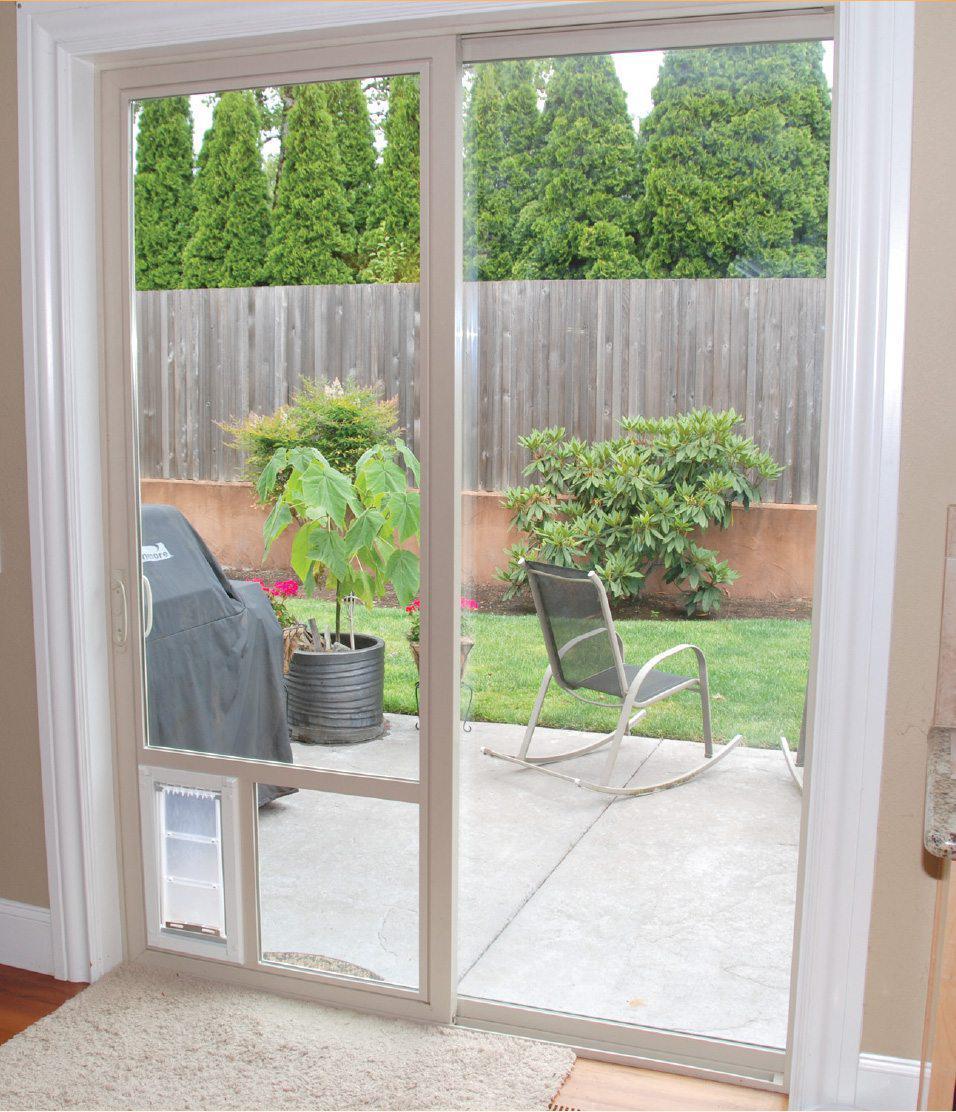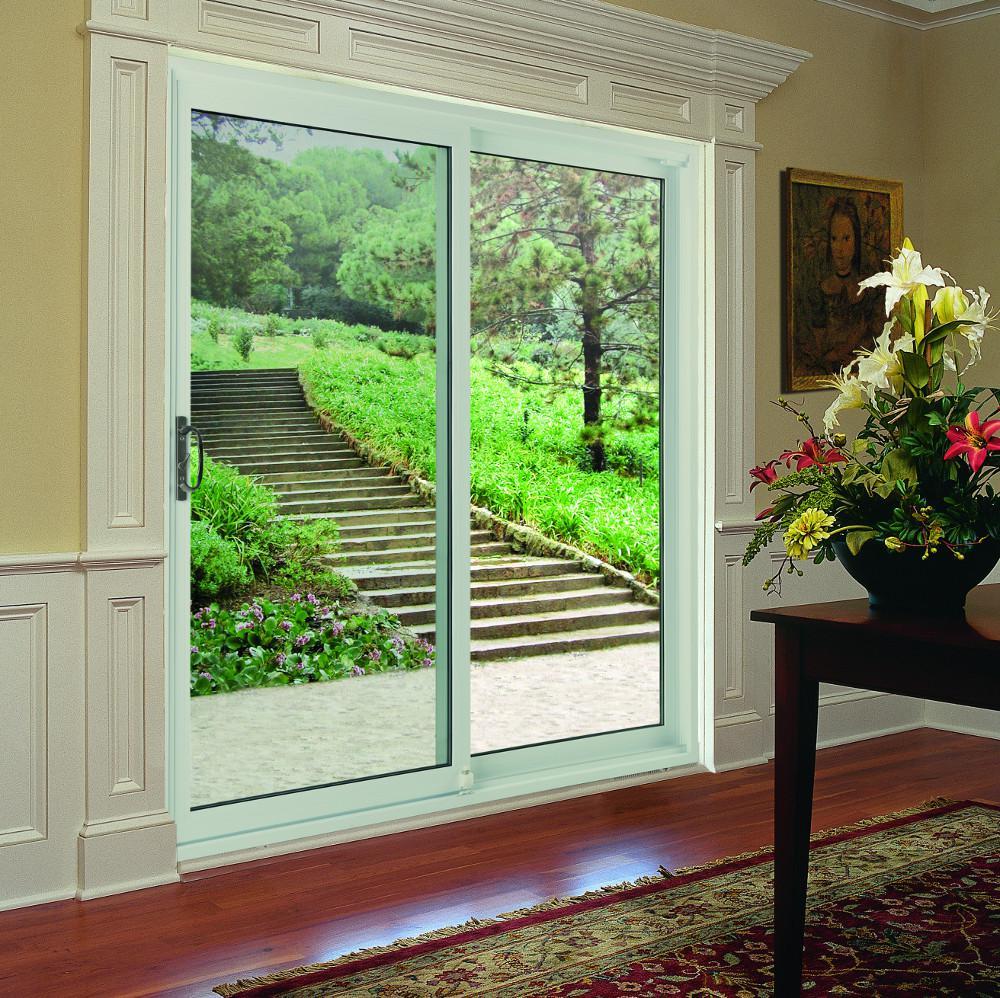The first image is the image on the left, the second image is the image on the right. Considering the images on both sides, is "All the doors are closed." valid? Answer yes or no. Yes. The first image is the image on the left, the second image is the image on the right. Analyze the images presented: Is the assertion "There is at least one chair visible through the sliding glass doors." valid? Answer yes or no. Yes. 